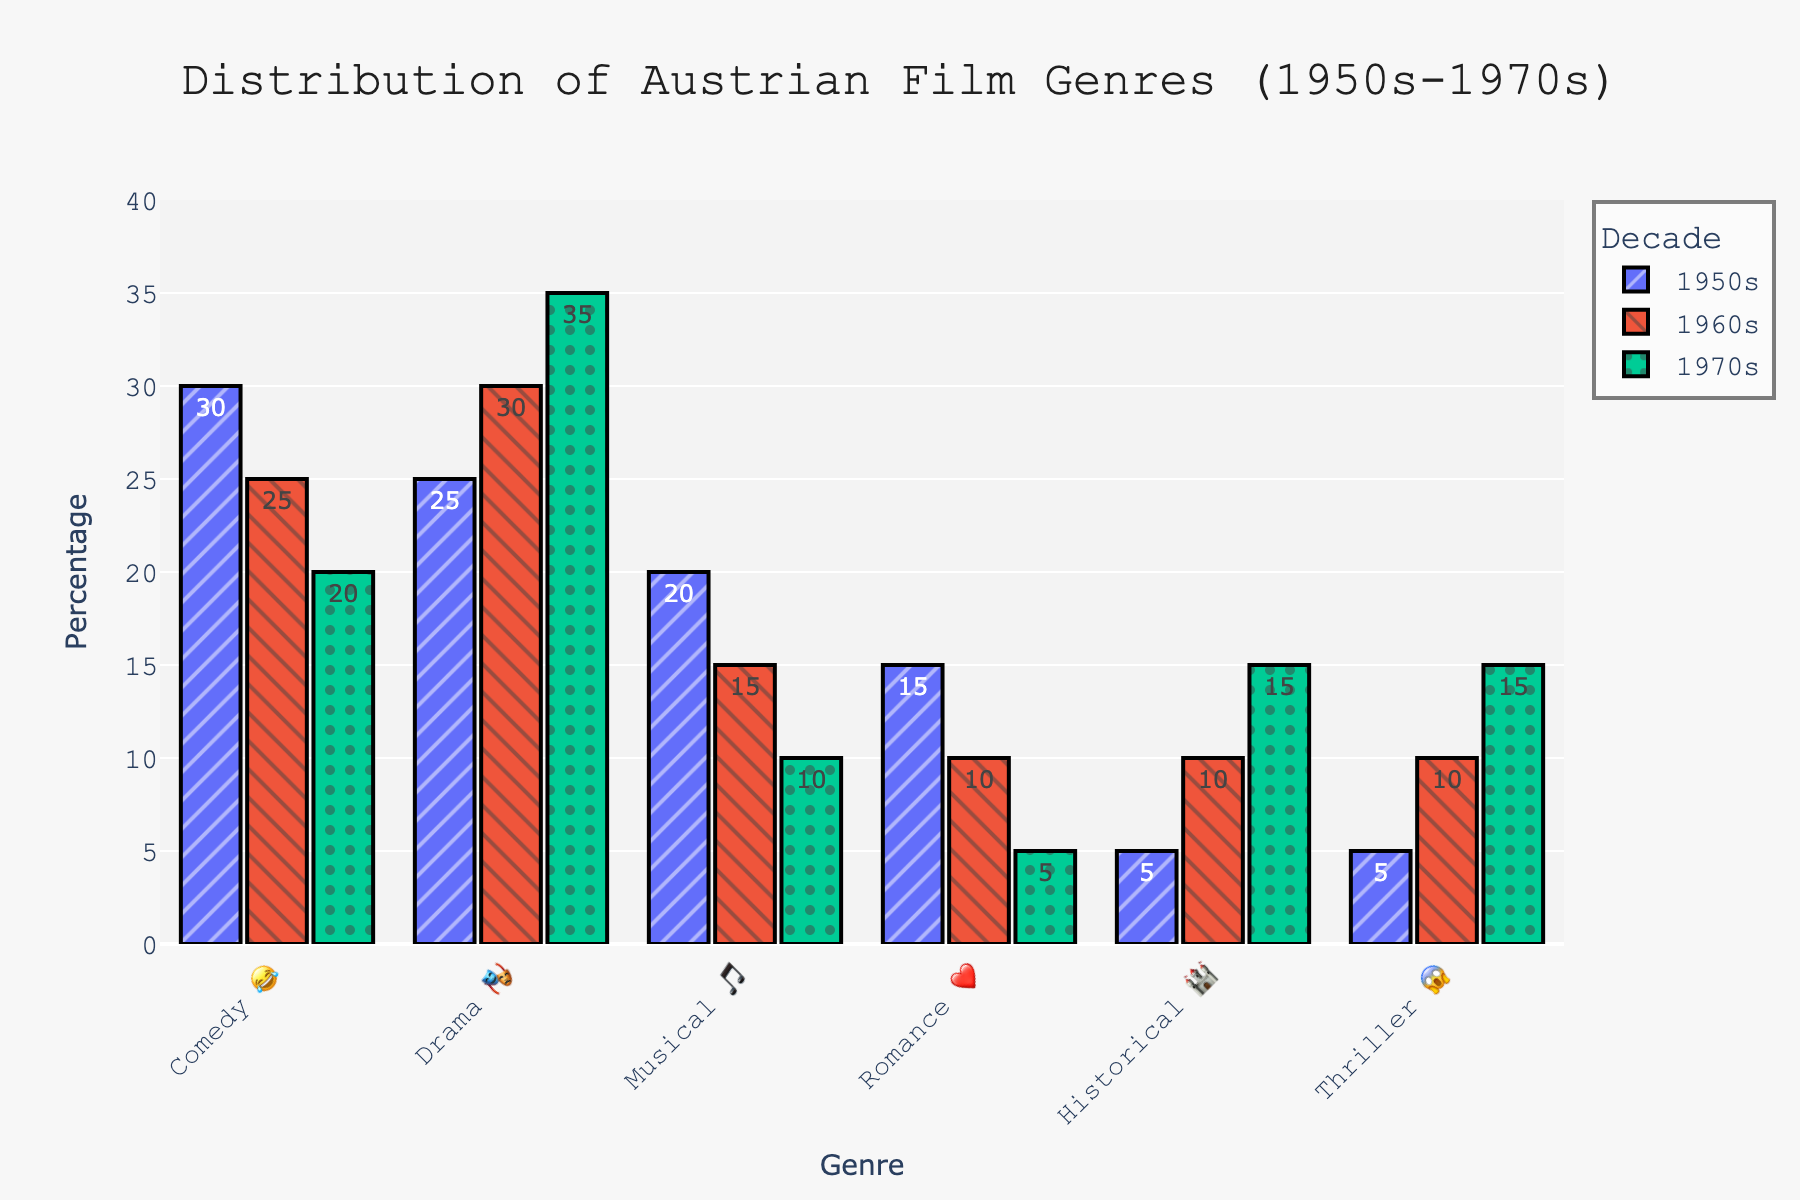What is the title of the chart? The title is typically displayed at the top of the chart in larger and bold font. It summarizes the main information presented in the chart.
Answer: Distribution of Austrian Film Genres (1950s-1970s) Which genre had the highest percentage in the 1950s 😂? By looking at the bar heights for the 1950s, the tallest bar represents the highest percentage for that decade. The genre with the tallest bar in the 1950s is Comedy.
Answer: Comedy 😂 How did the percentage for the genre Historical 🏰 change from the 1950s to the 1970s? Check the bar heights for Historical in the 1950s, 1960s, and 1970s. The percentage increased from 5% in the 1950s to 10% in the 1960s, and to 15% in the 1970s. The change is an increase by 5% each decade.
Answer: It increased During which decade did Thriller 😱 and Historical 🏰 genres have equal percentages? Compare the bar heights for Thriller and Historical across the decades. They both reached 10% in the 1960s.
Answer: 1960s What is the sum of the percentages for the genre Drama 🎭 across all three decades? Add the percentages for Drama in the 1950s, 1960s, and 1970s: 25% + 30% + 35%.
Answer: 90% How much did the percentage of Musical 🎵 decline from the 1950s to the 1970s? Subtract the 1970s percentage for Musical (10%) from the 1950s percentage (20%).
Answer: 10% Which genre had an increasing trend in percentage over the decades? Check the bars for each genre across decades. Historical 🏰 and Thriller 😱 both showed an increasing trend.
Answer: Historical 🏰 and Thriller 😱 In which decade was Romance ❤️ most popular? Identify the decade where the bar for Romance is highest. The highest bar for Romance is in the 1950s.
Answer: 1950s Which genre's popularity decreased the most from the 1950s to the 1970s? Compare the percentage drops for each genre from the 1950s to the 1970s. Romance decreased from 15% to 5%, making it a 10% decrease.
Answer: Romance ❤️ What was the most popular genre in the 1970s? Looking at the tallest bar for the 1970s will identify the most popular genre for that decade. The tallest bar for the 1970s is Drama.
Answer: Drama 🎭 